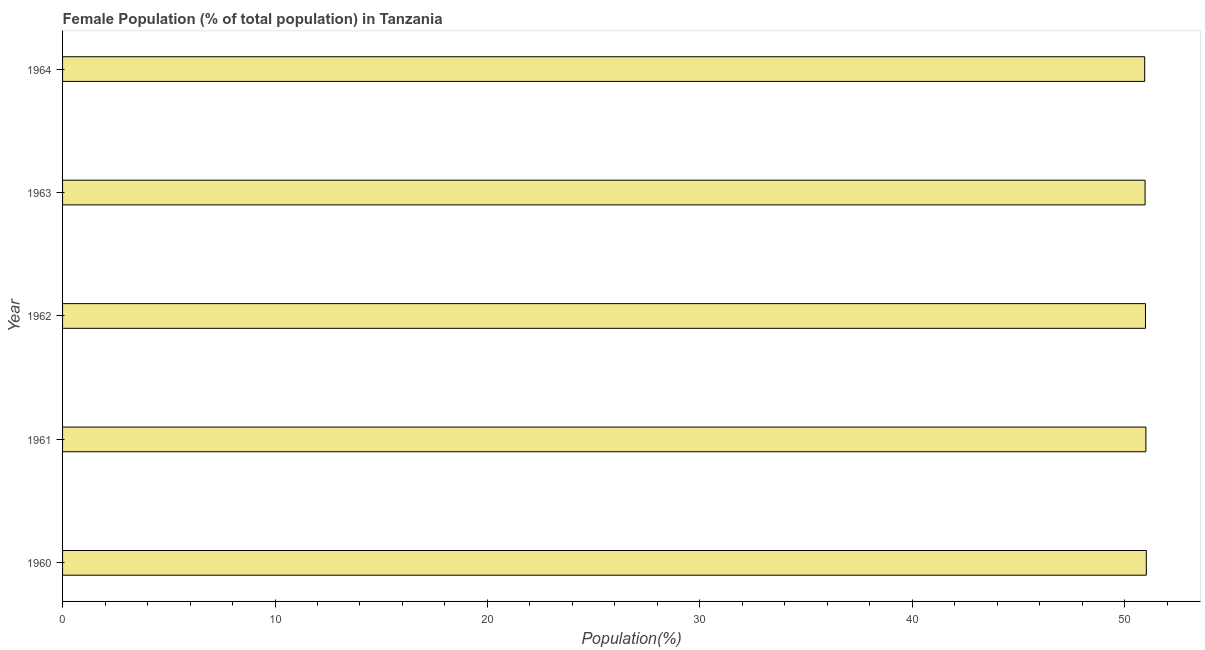What is the title of the graph?
Make the answer very short. Female Population (% of total population) in Tanzania. What is the label or title of the X-axis?
Give a very brief answer. Population(%). What is the female population in 1961?
Provide a short and direct response. 51. Across all years, what is the maximum female population?
Keep it short and to the point. 51.01. Across all years, what is the minimum female population?
Provide a succinct answer. 50.94. In which year was the female population minimum?
Offer a terse response. 1964. What is the sum of the female population?
Provide a succinct answer. 254.88. What is the difference between the female population in 1962 and 1964?
Make the answer very short. 0.04. What is the average female population per year?
Make the answer very short. 50.98. What is the median female population?
Give a very brief answer. 50.98. Is the difference between the female population in 1963 and 1964 greater than the difference between any two years?
Your answer should be very brief. No. What is the difference between the highest and the second highest female population?
Provide a succinct answer. 0.02. In how many years, is the female population greater than the average female population taken over all years?
Your answer should be compact. 2. What is the difference between two consecutive major ticks on the X-axis?
Offer a terse response. 10. Are the values on the major ticks of X-axis written in scientific E-notation?
Your response must be concise. No. What is the Population(%) in 1960?
Make the answer very short. 51.01. What is the Population(%) in 1961?
Provide a short and direct response. 51. What is the Population(%) of 1962?
Keep it short and to the point. 50.98. What is the Population(%) of 1963?
Ensure brevity in your answer.  50.96. What is the Population(%) of 1964?
Provide a short and direct response. 50.94. What is the difference between the Population(%) in 1960 and 1961?
Your answer should be compact. 0.02. What is the difference between the Population(%) in 1960 and 1962?
Provide a succinct answer. 0.04. What is the difference between the Population(%) in 1960 and 1963?
Provide a short and direct response. 0.06. What is the difference between the Population(%) in 1960 and 1964?
Provide a succinct answer. 0.08. What is the difference between the Population(%) in 1961 and 1962?
Keep it short and to the point. 0.02. What is the difference between the Population(%) in 1961 and 1963?
Offer a terse response. 0.04. What is the difference between the Population(%) in 1961 and 1964?
Make the answer very short. 0.06. What is the difference between the Population(%) in 1962 and 1963?
Provide a short and direct response. 0.02. What is the difference between the Population(%) in 1962 and 1964?
Ensure brevity in your answer.  0.04. What is the difference between the Population(%) in 1963 and 1964?
Provide a succinct answer. 0.02. What is the ratio of the Population(%) in 1960 to that in 1961?
Your answer should be very brief. 1. What is the ratio of the Population(%) in 1960 to that in 1962?
Keep it short and to the point. 1. What is the ratio of the Population(%) in 1961 to that in 1962?
Keep it short and to the point. 1. What is the ratio of the Population(%) in 1961 to that in 1963?
Offer a terse response. 1. What is the ratio of the Population(%) in 1962 to that in 1963?
Offer a terse response. 1. What is the ratio of the Population(%) in 1963 to that in 1964?
Provide a short and direct response. 1. 